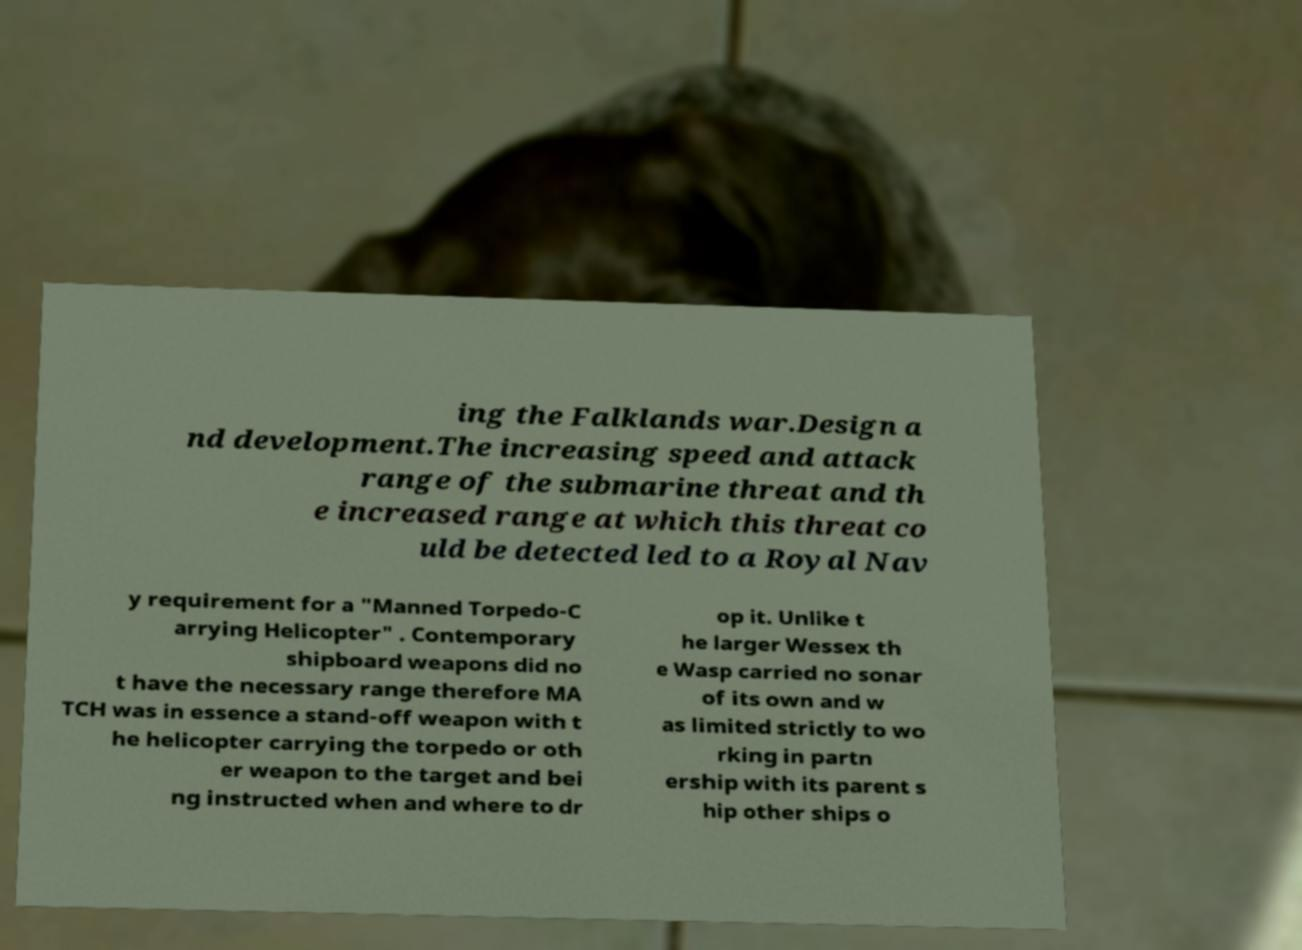Please read and relay the text visible in this image. What does it say? ing the Falklands war.Design a nd development.The increasing speed and attack range of the submarine threat and th e increased range at which this threat co uld be detected led to a Royal Nav y requirement for a "Manned Torpedo-C arrying Helicopter" . Contemporary shipboard weapons did no t have the necessary range therefore MA TCH was in essence a stand-off weapon with t he helicopter carrying the torpedo or oth er weapon to the target and bei ng instructed when and where to dr op it. Unlike t he larger Wessex th e Wasp carried no sonar of its own and w as limited strictly to wo rking in partn ership with its parent s hip other ships o 